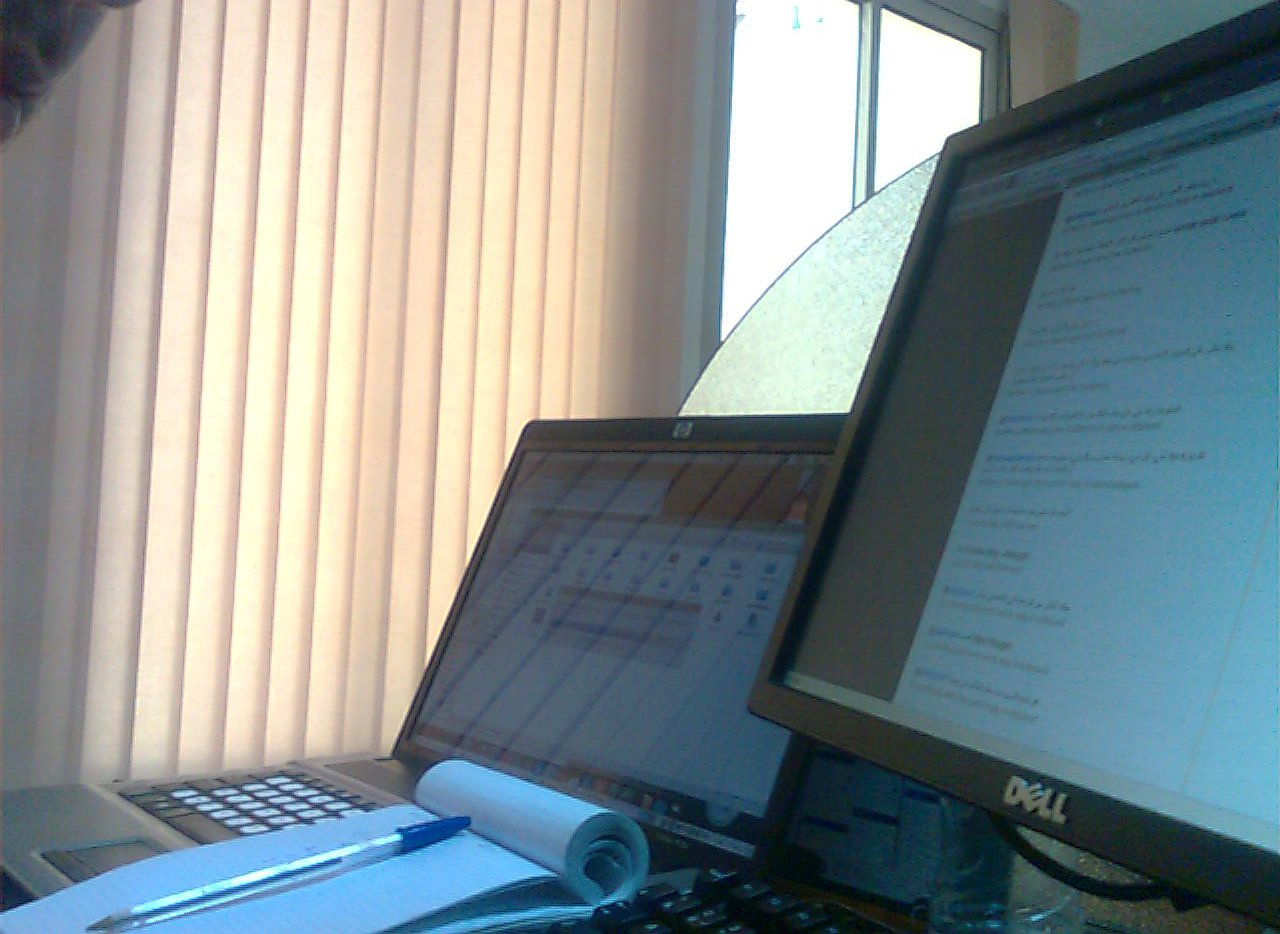Are there doors that are made of wood? No visible doors in the image are made of wood. The view primarily features technological and office-related items. 